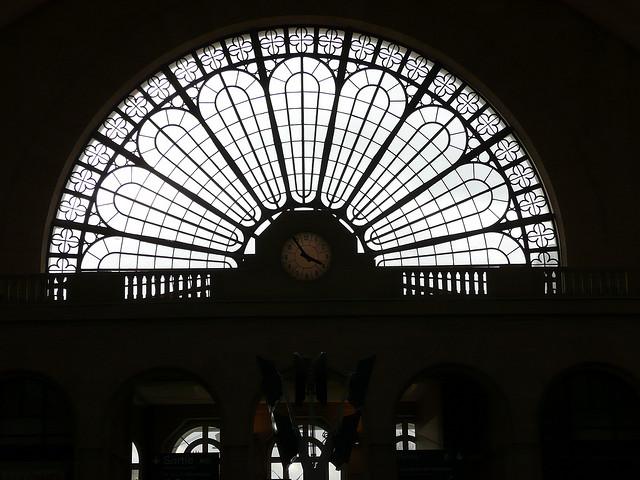<image>What shape are the holes in the ceiling? It is unknown what shape the holes in the ceiling are. There may not be any holes. What shape are the holes in the ceiling? I am not sure what shape the holes in the ceiling are. It can be seen round, arches, half circle, square, oval or odd shapes. 